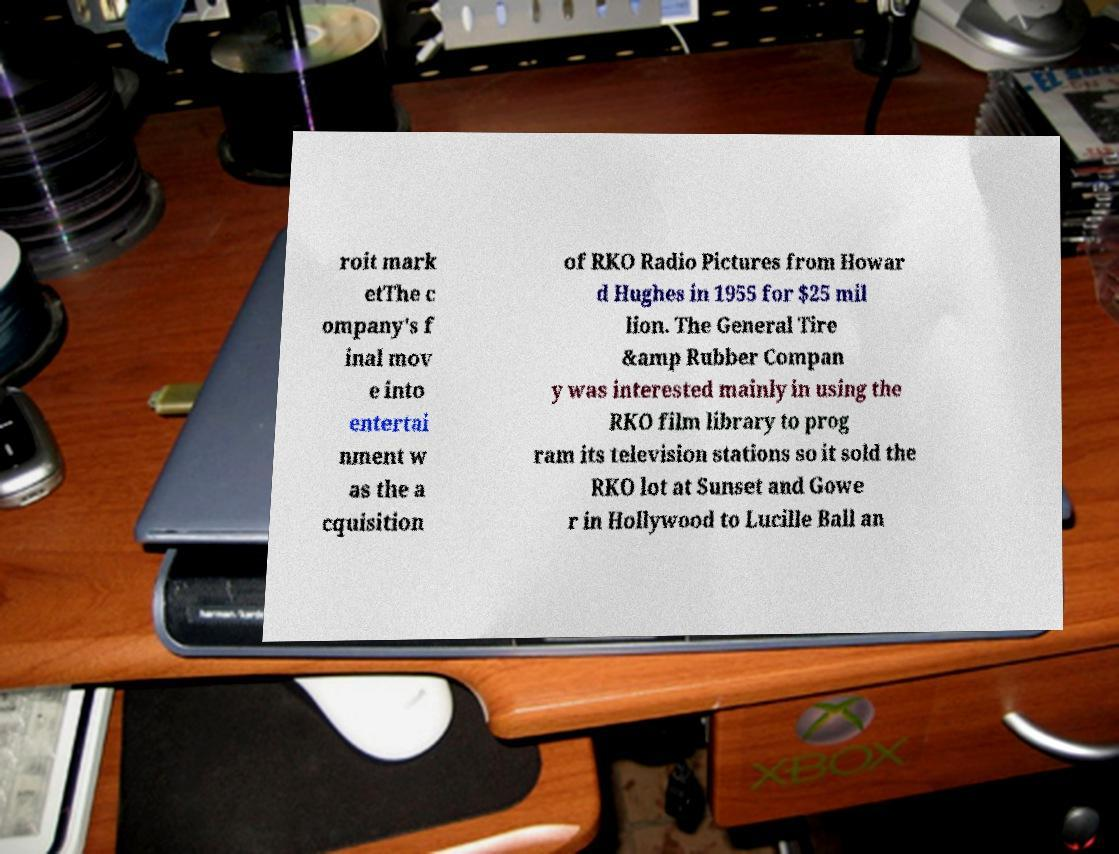Could you assist in decoding the text presented in this image and type it out clearly? roit mark etThe c ompany's f inal mov e into entertai nment w as the a cquisition of RKO Radio Pictures from Howar d Hughes in 1955 for $25 mil lion. The General Tire &amp Rubber Compan y was interested mainly in using the RKO film library to prog ram its television stations so it sold the RKO lot at Sunset and Gowe r in Hollywood to Lucille Ball an 